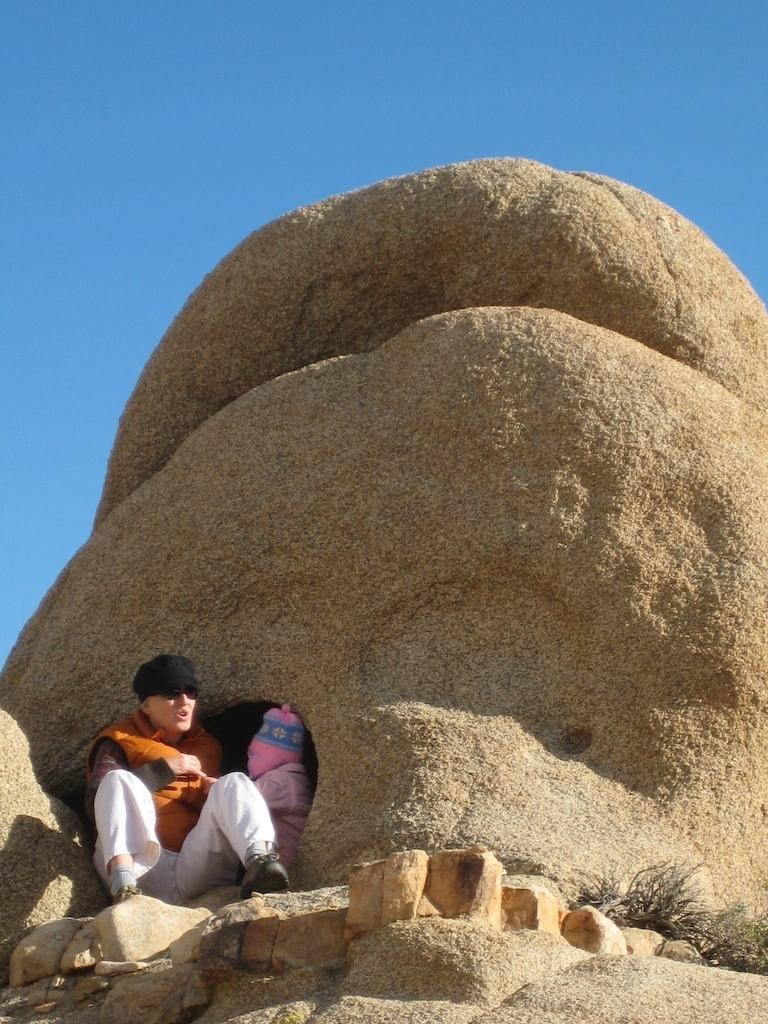How many people are in the image? There are two persons on the left side of the image. What can be seen in the middle of the image? There is a rock in the middle of the image. What is visible in the background of the image? The sky is visible in the background of the image. How many mice can be seen running around the rock in the image? There are no mice present in the image; it only features two persons and a rock. What type of experience can be gained from touching the rock in the image? There is no information about touching the rock or any related experience in the image. 